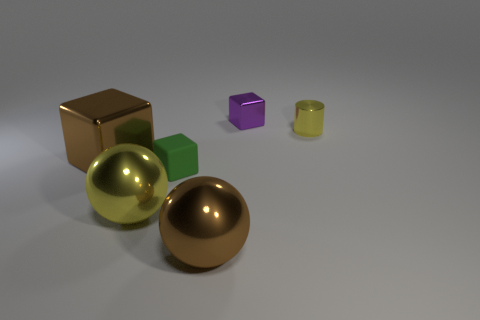Are there any patterns or consistency in the arrangement of the objects? The objects do not exhibit any obvious patterns or consistency in their arrangement; they are placed randomly across the surface. 